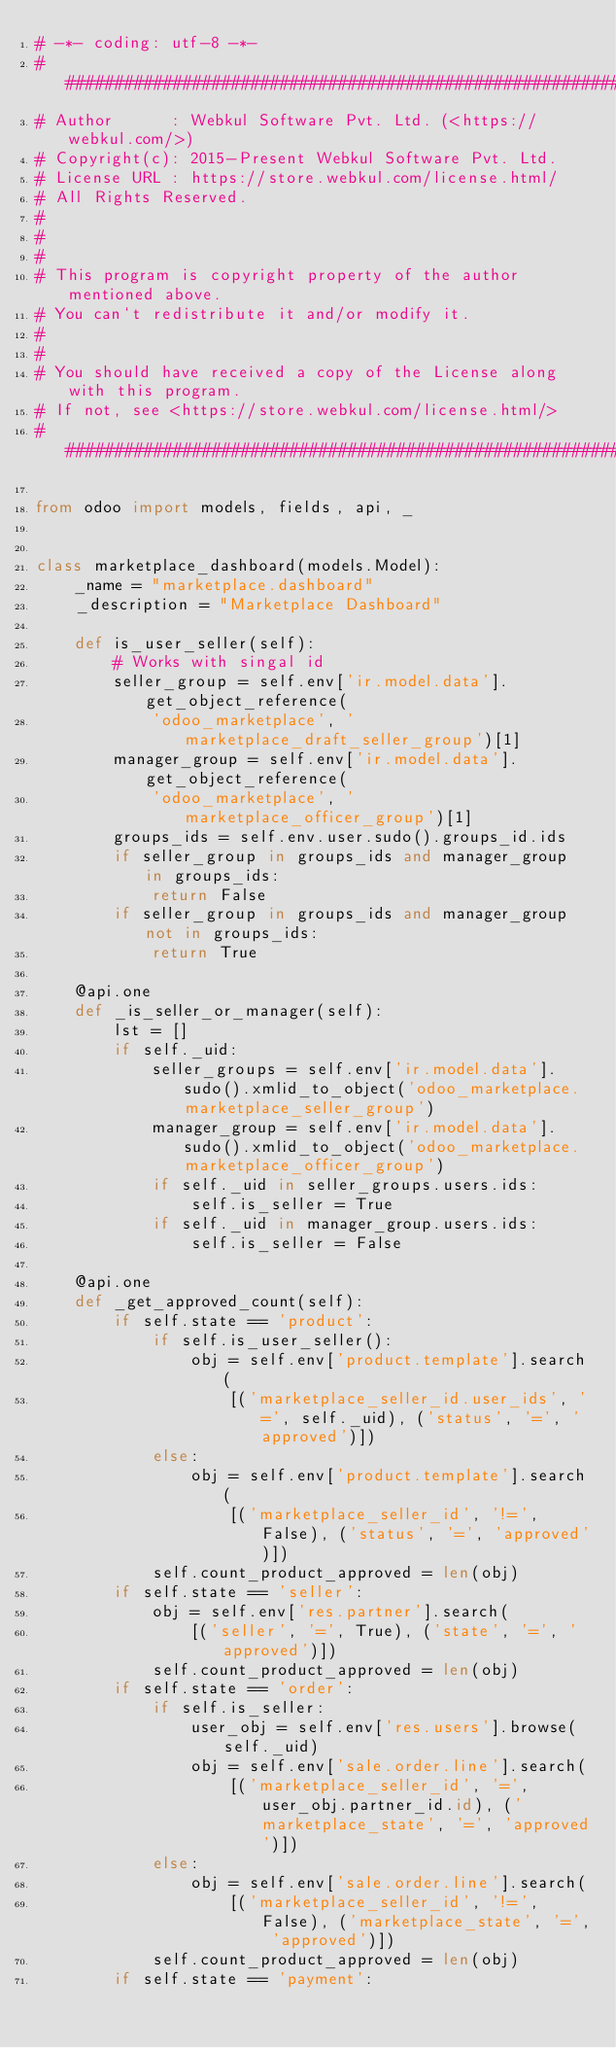<code> <loc_0><loc_0><loc_500><loc_500><_Python_># -*- coding: utf-8 -*-
#################################################################################
# Author      : Webkul Software Pvt. Ltd. (<https://webkul.com/>)
# Copyright(c): 2015-Present Webkul Software Pvt. Ltd.
# License URL : https://store.webkul.com/license.html/
# All Rights Reserved.
#
#
#
# This program is copyright property of the author mentioned above.
# You can`t redistribute it and/or modify it.
#
#
# You should have received a copy of the License along with this program.
# If not, see <https://store.webkul.com/license.html/>
#################################################################################

from odoo import models, fields, api, _


class marketplace_dashboard(models.Model):
    _name = "marketplace.dashboard"
    _description = "Marketplace Dashboard"

    def is_user_seller(self):
        # Works with singal id
        seller_group = self.env['ir.model.data'].get_object_reference(
            'odoo_marketplace', 'marketplace_draft_seller_group')[1]
        manager_group = self.env['ir.model.data'].get_object_reference(
            'odoo_marketplace', 'marketplace_officer_group')[1]
        groups_ids = self.env.user.sudo().groups_id.ids
        if seller_group in groups_ids and manager_group in groups_ids:
            return False
        if seller_group in groups_ids and manager_group not in groups_ids:
            return True

    @api.one
    def _is_seller_or_manager(self):
        lst = []
        if self._uid:
            seller_groups = self.env['ir.model.data'].sudo().xmlid_to_object('odoo_marketplace.marketplace_seller_group')
            manager_group = self.env['ir.model.data'].sudo().xmlid_to_object('odoo_marketplace.marketplace_officer_group')
            if self._uid in seller_groups.users.ids:
                self.is_seller = True
            if self._uid in manager_group.users.ids:
                self.is_seller = False

    @api.one
    def _get_approved_count(self):
        if self.state == 'product':
            if self.is_user_seller():
                obj = self.env['product.template'].search(
                    [('marketplace_seller_id.user_ids', '=', self._uid), ('status', '=', 'approved')])
            else:
                obj = self.env['product.template'].search(
                    [('marketplace_seller_id', '!=', False), ('status', '=', 'approved')])
            self.count_product_approved = len(obj)
        if self.state == 'seller':
            obj = self.env['res.partner'].search(
                [('seller', '=', True), ('state', '=', 'approved')])
            self.count_product_approved = len(obj)
        if self.state == 'order':
            if self.is_seller:
                user_obj = self.env['res.users'].browse(self._uid)
                obj = self.env['sale.order.line'].search(
                    [('marketplace_seller_id', '=',user_obj.partner_id.id), ('marketplace_state', '=', 'approved')])
            else:
                obj = self.env['sale.order.line'].search(
                    [('marketplace_seller_id', '!=', False), ('marketplace_state', '=', 'approved')])
            self.count_product_approved = len(obj)
        if self.state == 'payment':</code> 